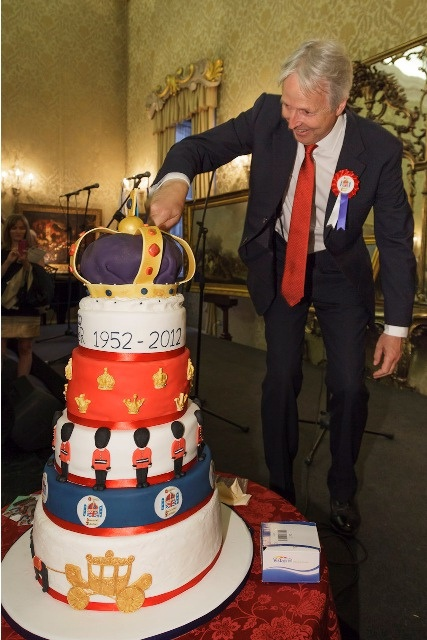Describe the objects in this image and their specific colors. I can see people in beige, black, gray, tan, and brown tones, cake in beige, lightgray, black, orange, and tan tones, dining table in beige, maroon, brown, black, and darkgray tones, people in beige, black, maroon, and gray tones, and tie in beige, brown, maroon, and black tones in this image. 